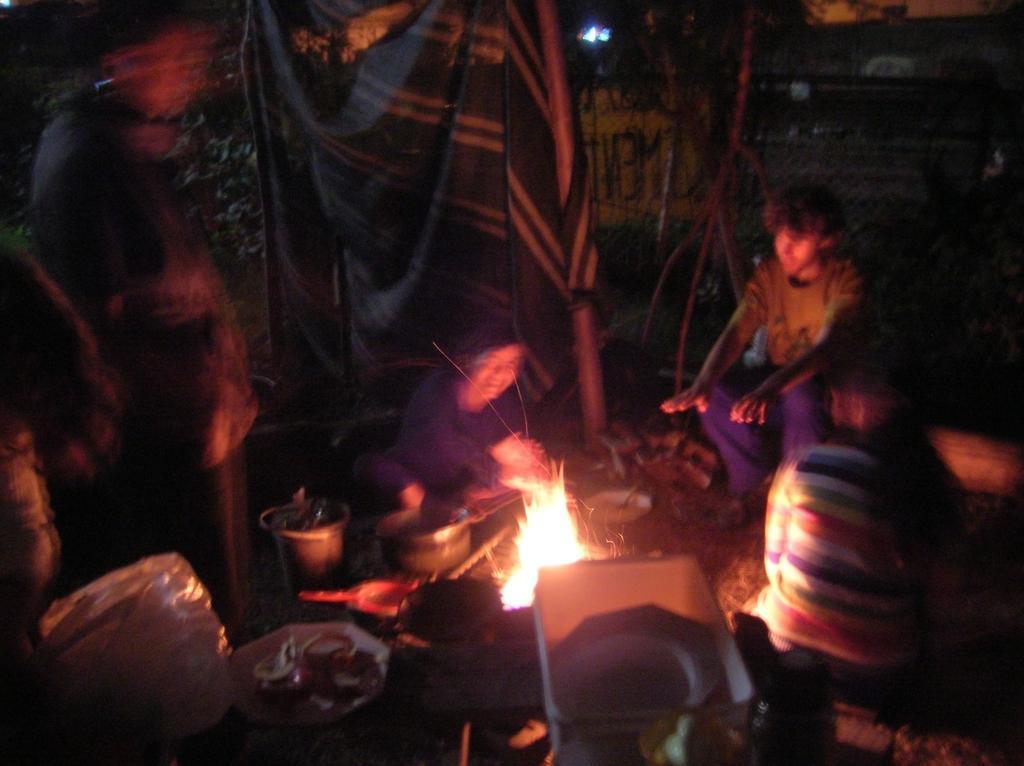In one or two sentences, can you explain what this image depicts? On the left side, there is a person standing. Beside this person, there are some objects. On the right side, there are two persons sitting. Beside them, there is a fire, there is a person smiling and there are other objects. In the background, there is a cloth and there is a light. And the background is dark in color. 